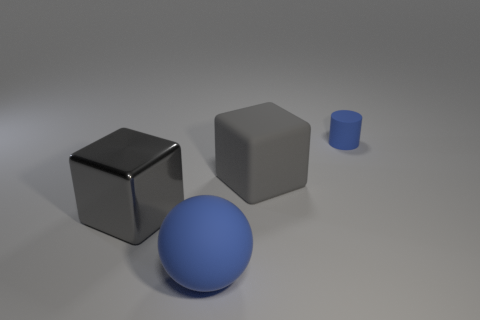How many big rubber objects are both left of the large gray rubber cube and behind the blue rubber ball?
Keep it short and to the point. 0. How many blocks are gray shiny things or small rubber objects?
Provide a succinct answer. 1. Are any big green rubber things visible?
Give a very brief answer. No. What number of other objects are there of the same material as the big blue sphere?
Provide a short and direct response. 2. There is another cube that is the same size as the gray matte cube; what is it made of?
Provide a short and direct response. Metal. Does the large matte object that is to the right of the big ball have the same shape as the gray shiny object?
Ensure brevity in your answer.  Yes. Does the large rubber cube have the same color as the big metal block?
Offer a terse response. Yes. How many things are cubes that are behind the gray metallic object or large gray metallic things?
Offer a very short reply. 2. The rubber thing that is the same size as the blue rubber sphere is what shape?
Ensure brevity in your answer.  Cube. Do the block to the right of the rubber ball and the gray metallic thing that is behind the large blue matte sphere have the same size?
Offer a terse response. Yes. 